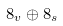<formula> <loc_0><loc_0><loc_500><loc_500>8 _ { v } \oplus 8 _ { s }</formula> 